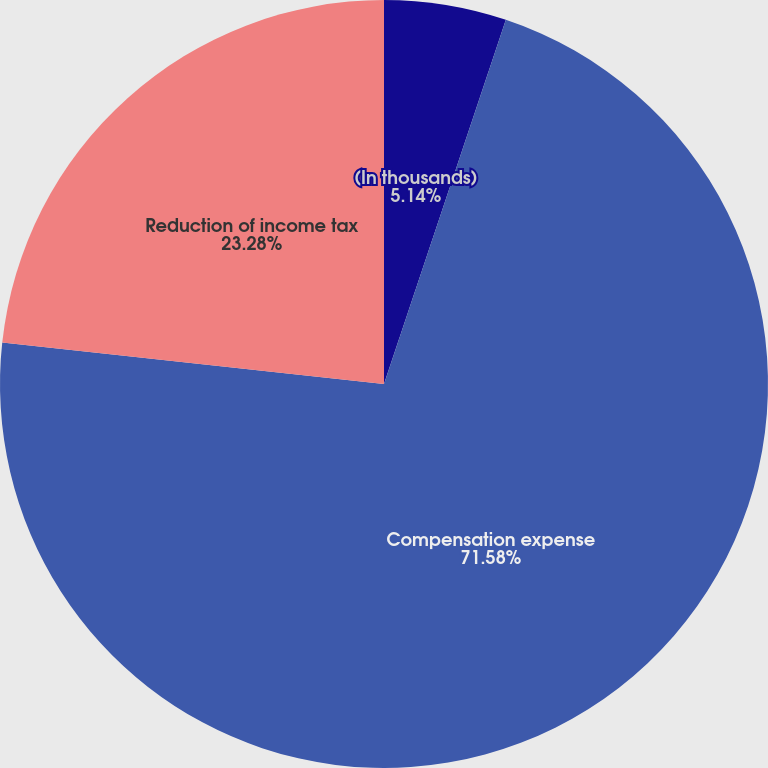Convert chart to OTSL. <chart><loc_0><loc_0><loc_500><loc_500><pie_chart><fcel>(In thousands)<fcel>Compensation expense<fcel>Reduction of income tax<nl><fcel>5.14%<fcel>71.58%<fcel>23.28%<nl></chart> 